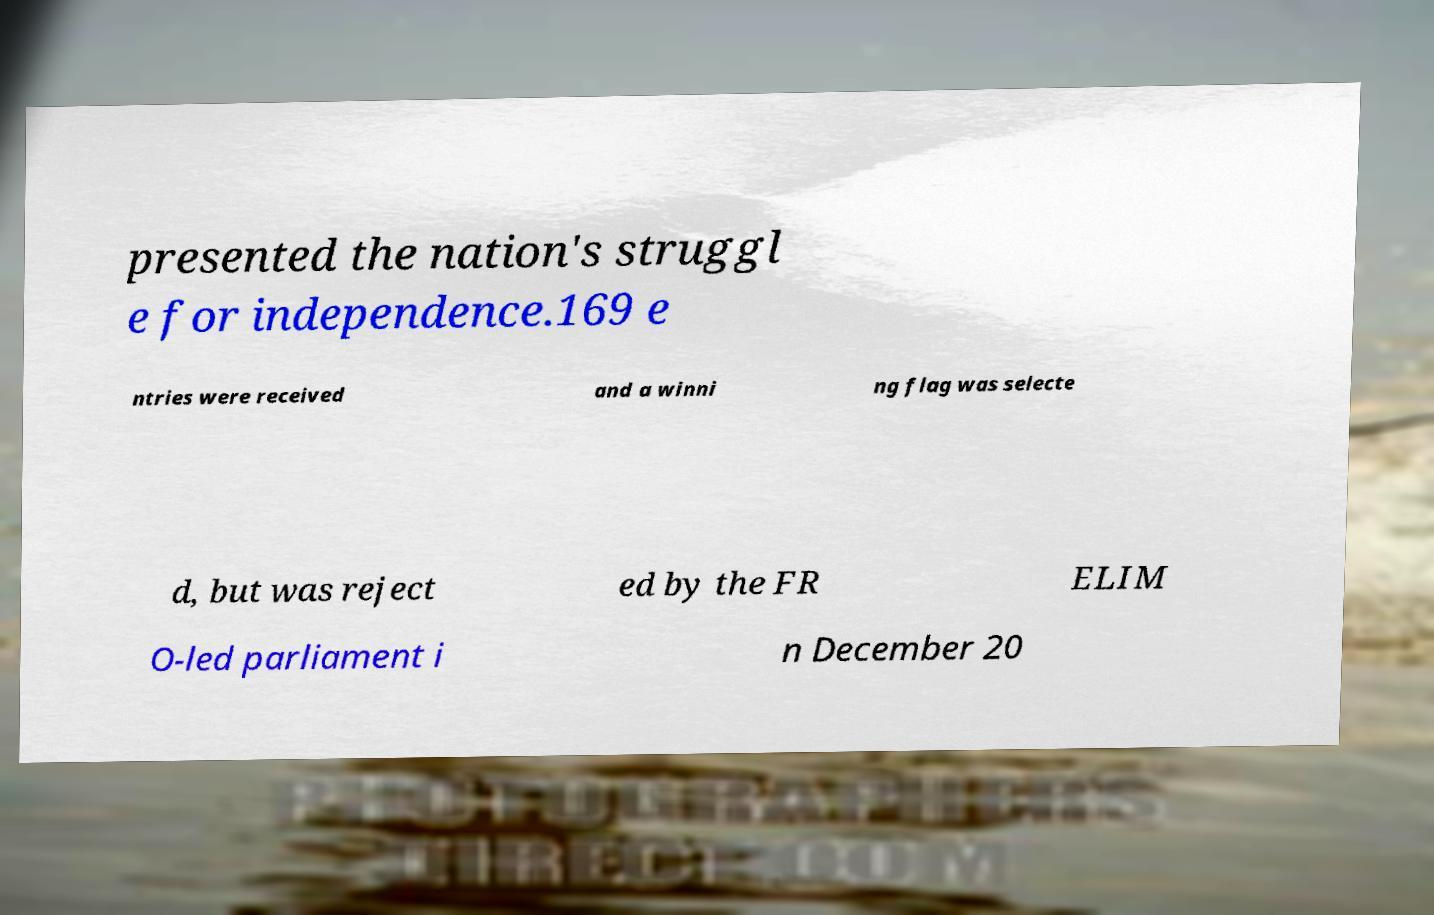Could you extract and type out the text from this image? presented the nation's struggl e for independence.169 e ntries were received and a winni ng flag was selecte d, but was reject ed by the FR ELIM O-led parliament i n December 20 